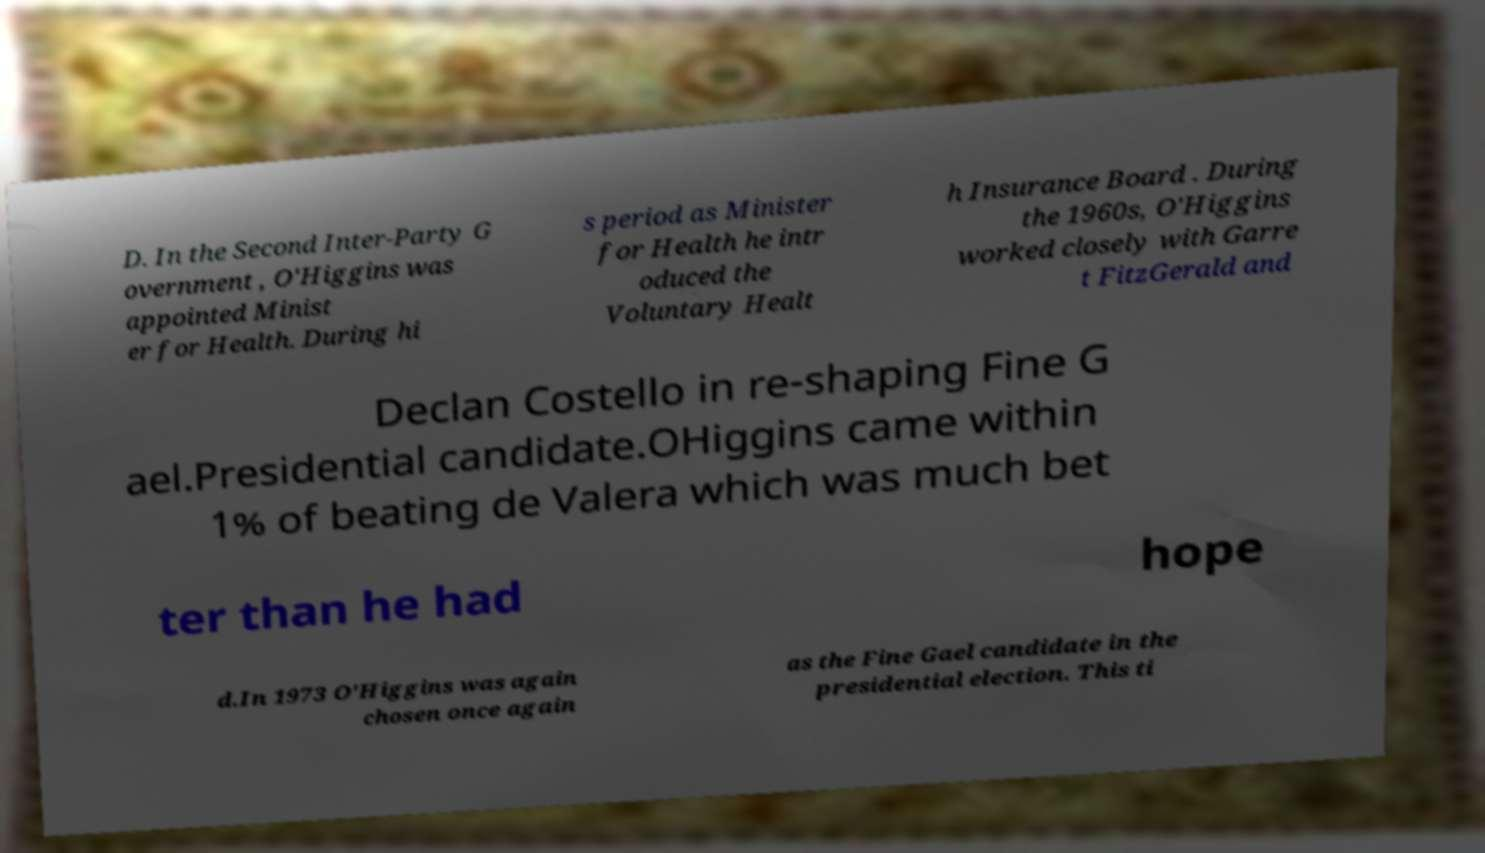What messages or text are displayed in this image? I need them in a readable, typed format. D. In the Second Inter-Party G overnment , O'Higgins was appointed Minist er for Health. During hi s period as Minister for Health he intr oduced the Voluntary Healt h Insurance Board . During the 1960s, O'Higgins worked closely with Garre t FitzGerald and Declan Costello in re-shaping Fine G ael.Presidential candidate.OHiggins came within 1% of beating de Valera which was much bet ter than he had hope d.In 1973 O'Higgins was again chosen once again as the Fine Gael candidate in the presidential election. This ti 